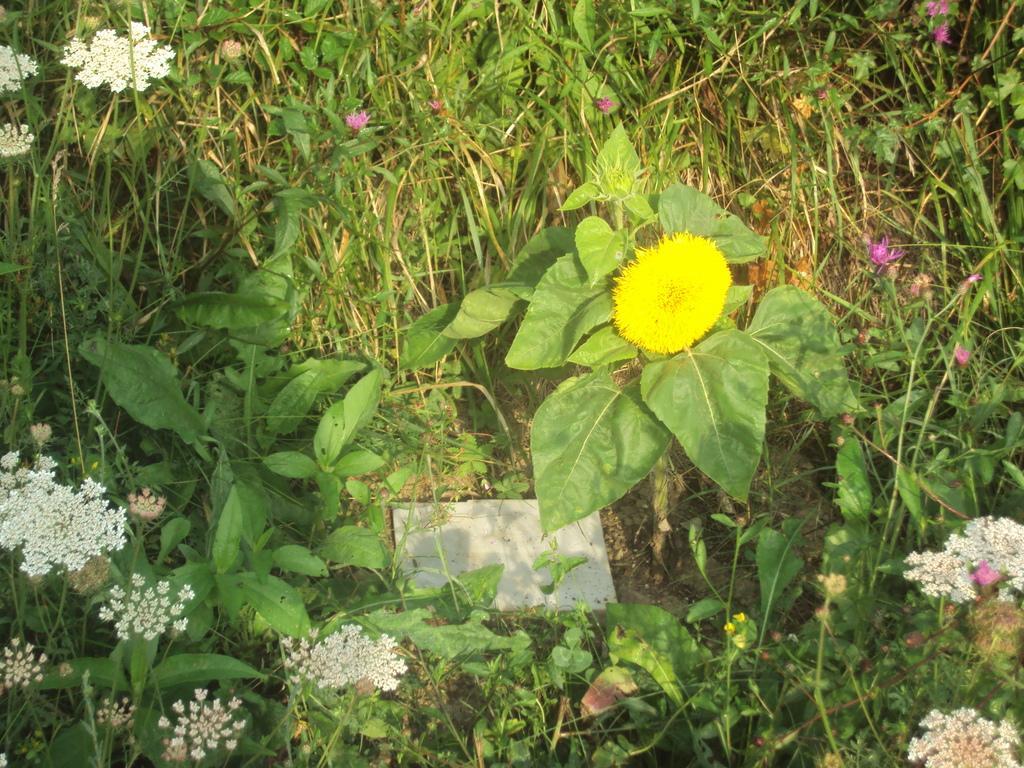Could you give a brief overview of what you see in this image? In this picture I can observe white and yellow color flowers to the plants. I can observe some plants in this picture. 